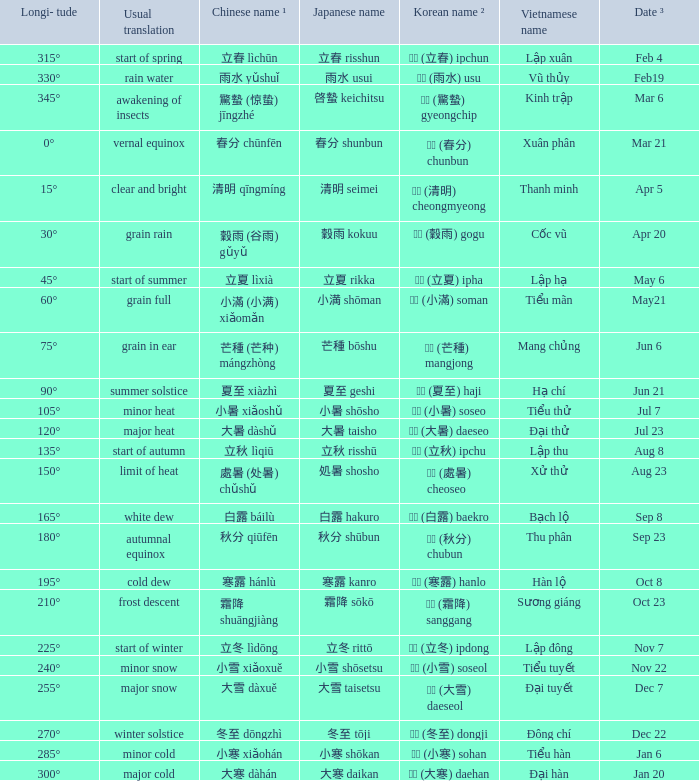WHICH Vietnamese name has a Chinese name ¹ of 芒種 (芒种) mángzhòng? Mang chủng. 